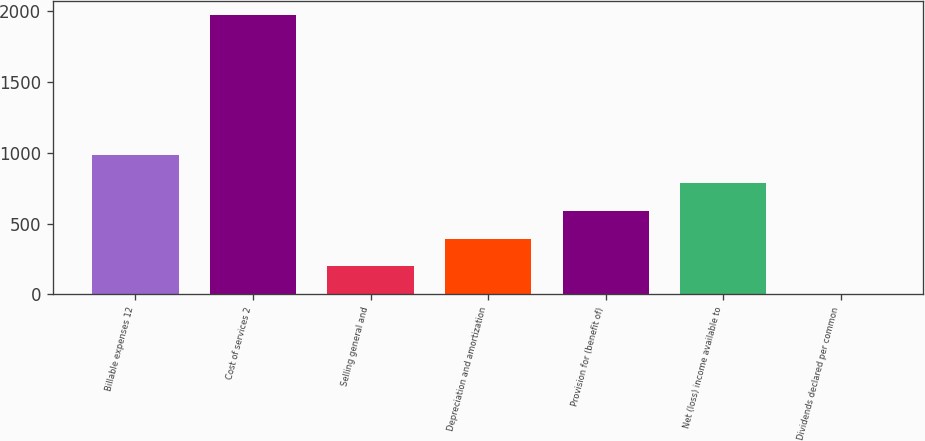Convert chart. <chart><loc_0><loc_0><loc_500><loc_500><bar_chart><fcel>Billable expenses 12<fcel>Cost of services 2<fcel>Selling general and<fcel>Depreciation and amortization<fcel>Provision for (benefit of)<fcel>Net (loss) income available to<fcel>Dividends declared per common<nl><fcel>985.21<fcel>1970.2<fcel>197.21<fcel>394.21<fcel>591.21<fcel>788.21<fcel>0.21<nl></chart> 